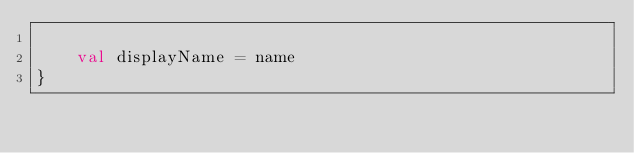<code> <loc_0><loc_0><loc_500><loc_500><_Kotlin_>
    val displayName = name
}</code> 